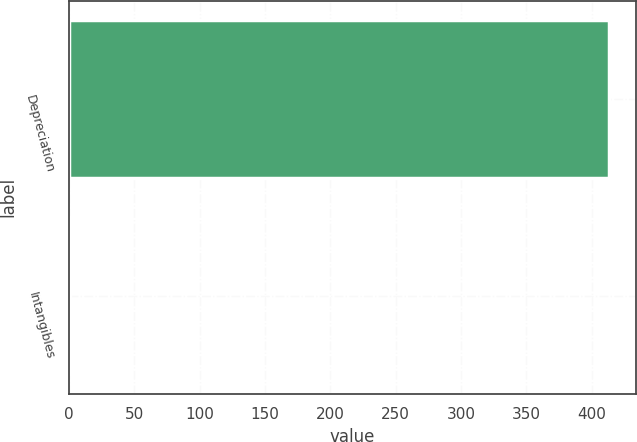Convert chart to OTSL. <chart><loc_0><loc_0><loc_500><loc_500><bar_chart><fcel>Depreciation<fcel>Intangibles<nl><fcel>413<fcel>1<nl></chart> 